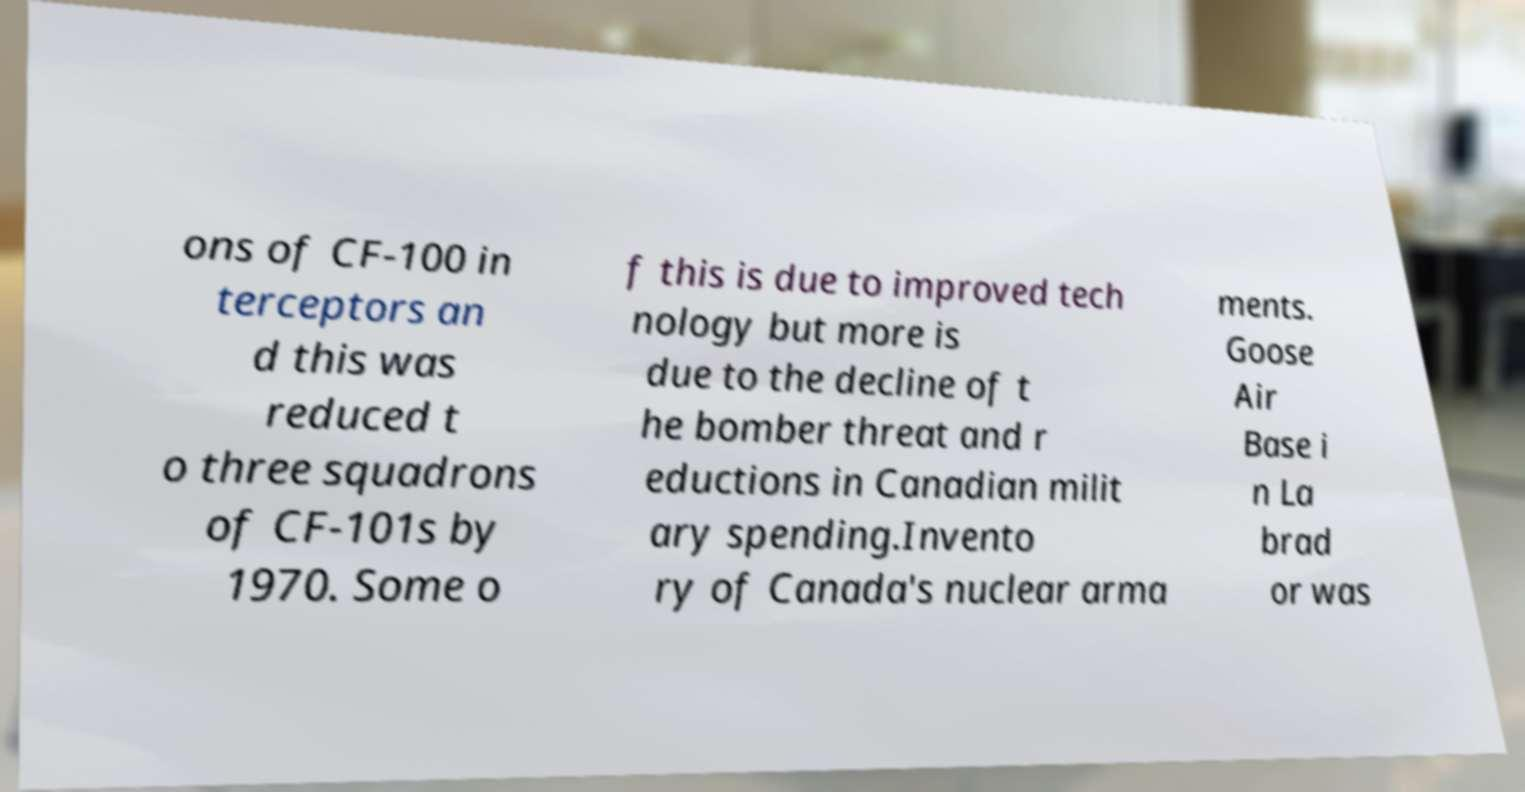There's text embedded in this image that I need extracted. Can you transcribe it verbatim? ons of CF-100 in terceptors an d this was reduced t o three squadrons of CF-101s by 1970. Some o f this is due to improved tech nology but more is due to the decline of t he bomber threat and r eductions in Canadian milit ary spending.Invento ry of Canada's nuclear arma ments. Goose Air Base i n La brad or was 